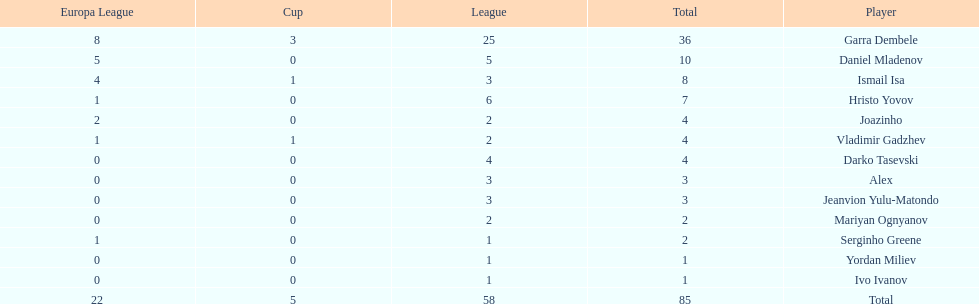Could you parse the entire table? {'header': ['Europa League', 'Cup', 'League', 'Total', 'Player'], 'rows': [['8', '3', '25', '36', 'Garra Dembele'], ['5', '0', '5', '10', 'Daniel Mladenov'], ['4', '1', '3', '8', 'Ismail Isa'], ['1', '0', '6', '7', 'Hristo Yovov'], ['2', '0', '2', '4', 'Joazinho'], ['1', '1', '2', '4', 'Vladimir Gadzhev'], ['0', '0', '4', '4', 'Darko Tasevski'], ['0', '0', '3', '3', 'Alex'], ['0', '0', '3', '3', 'Jeanvion Yulu-Matondo'], ['0', '0', '2', '2', 'Mariyan Ognyanov'], ['1', '0', '1', '2', 'Serginho Greene'], ['0', '0', '1', '1', 'Yordan Miliev'], ['0', '0', '1', '1', 'Ivo Ivanov'], ['22', '5', '58', '85', 'Total']]} Which players only scored one goal? Serginho Greene, Yordan Miliev, Ivo Ivanov. 